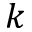<formula> <loc_0><loc_0><loc_500><loc_500>k</formula> 